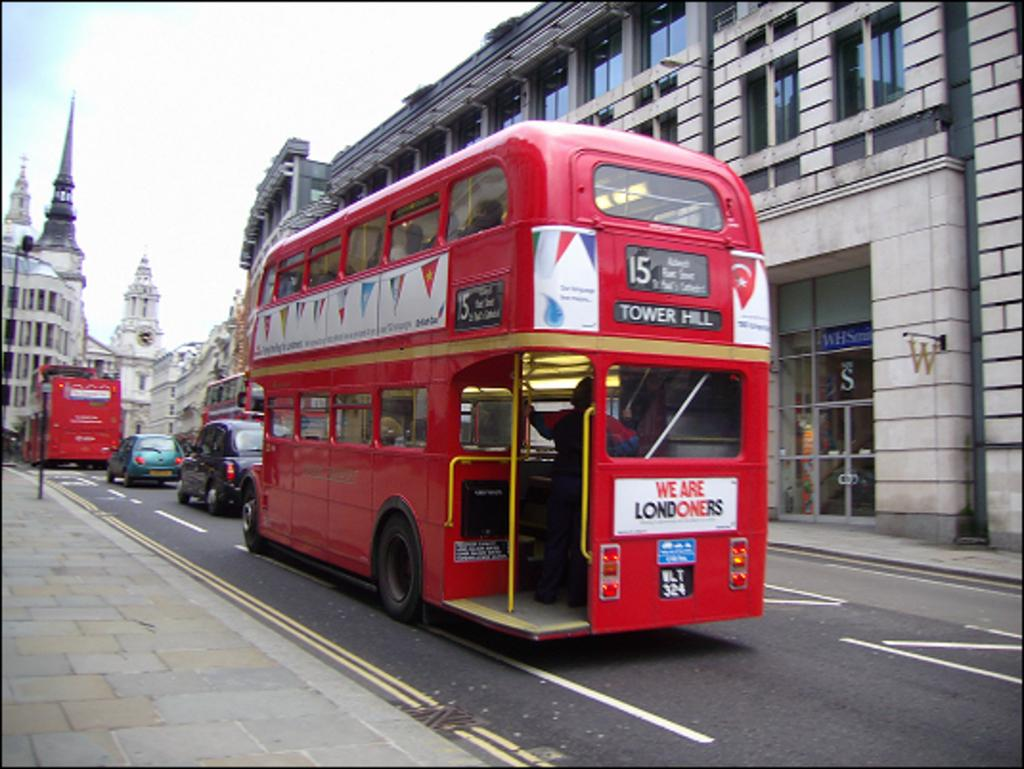Provide a one-sentence caption for the provided image. A double decker bus in London that is headed towards Tower Hill. 